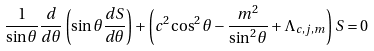<formula> <loc_0><loc_0><loc_500><loc_500>\frac { 1 } { \sin \theta } \frac { d } { d \theta } \left ( \sin \theta \frac { d S } { d \theta } \right ) + \left ( c ^ { 2 } \cos ^ { 2 } \theta - \frac { m ^ { 2 } } { \sin ^ { 2 } \theta } + \Lambda _ { c , j , m } \right ) S = 0</formula> 